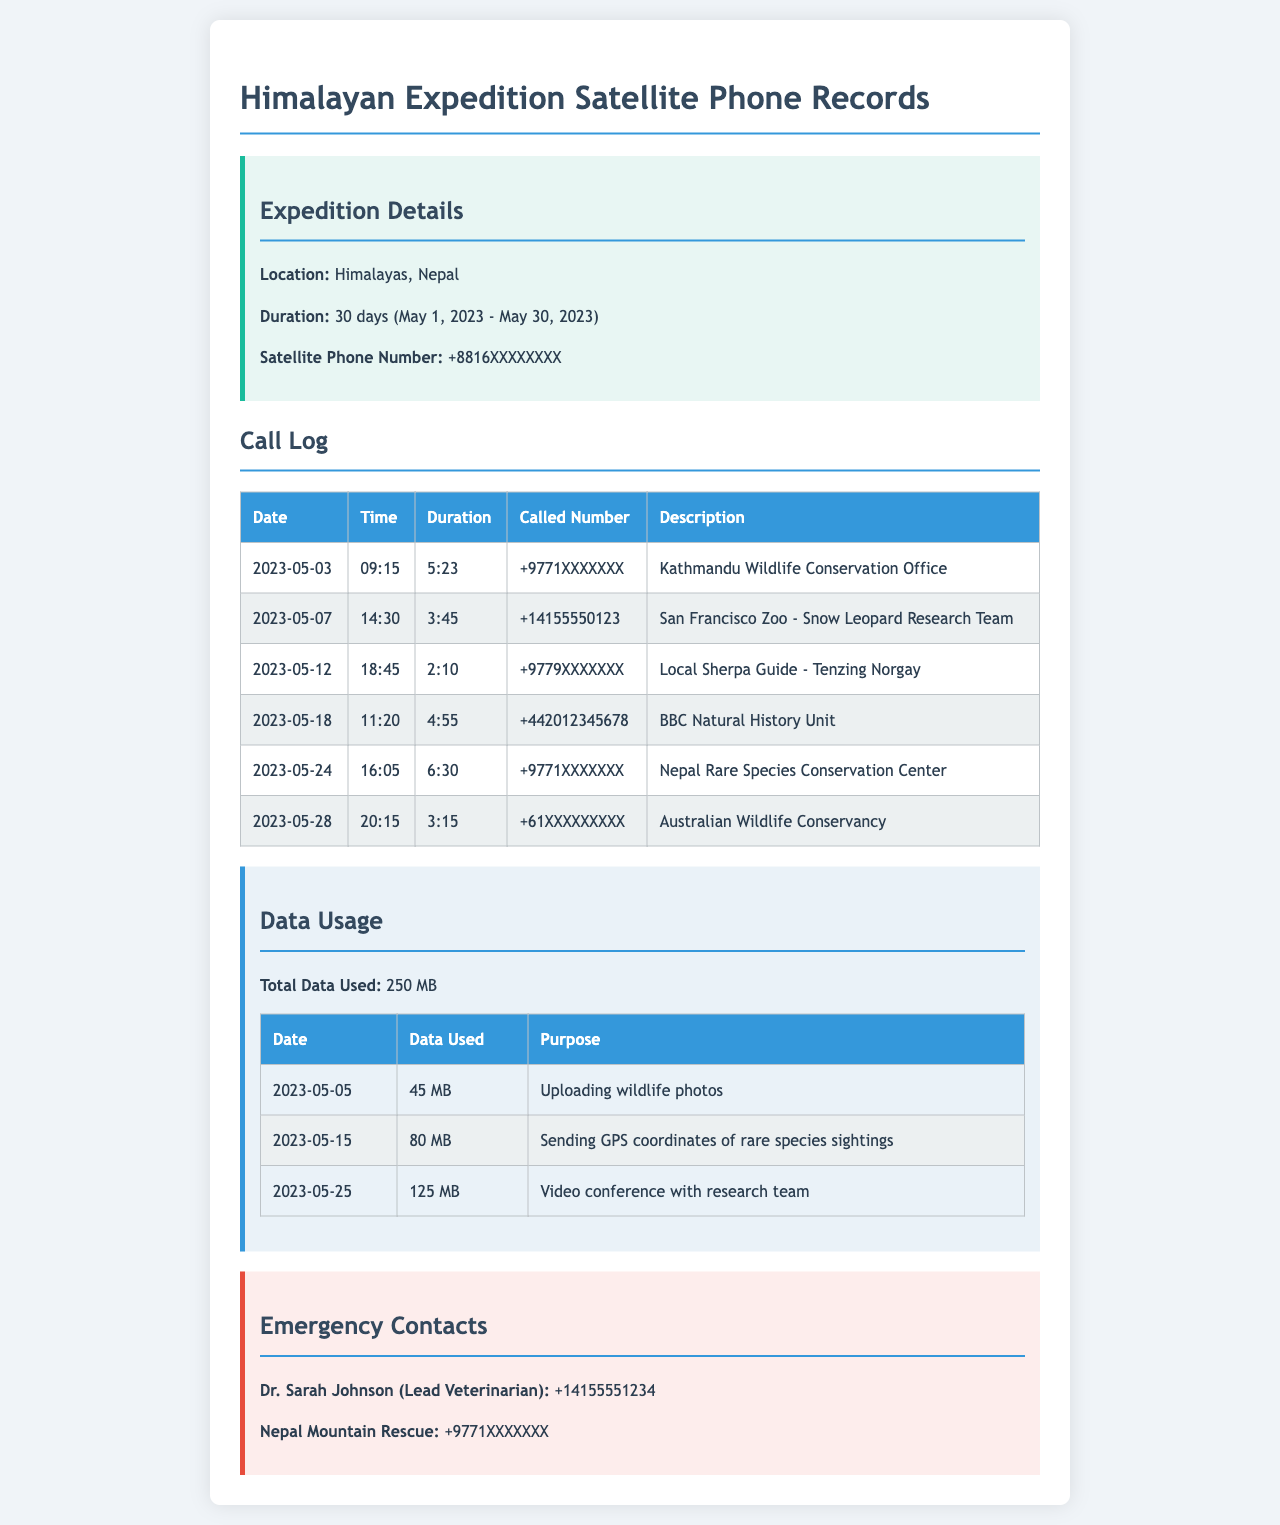what is the satellite phone number? The satellite phone number is a specific detail found in the expedition details section of the document.
Answer: +8816XXXXXXXX what is the total data used? The total data used is indicated clearly in the data usage section.
Answer: 250 MB which organization was contacted on May 7? This is identified in the call log section that lists the dates and corresponding organizations called.
Answer: San Francisco Zoo - Snow Leopard Research Team how long was the call made to the BBC Natural History Unit? The duration of the call to the BBC Natural History Unit is specified in the call log table.
Answer: 4:55 who is the lead veterinarian? The lead veterinarian's name is provided in the emergency contacts section of the document.
Answer: Dr. Sarah Johnson which date had the most data used? By comparing the data usage entries, we can identify the date with the highest data consumption.
Answer: 2023-05-25 how many calls were made to organizations in Nepal? This requires counting the entries in the call log that are affiliated with Nepal.
Answer: 3 what was the purpose of data used on May 15? The purpose of the data used is outlined in the data usage table next to the corresponding date.
Answer: Sending GPS coordinates of rare species sightings what type of document is this? This document contains records related to communication during an expedition, which is typical for maintaining contact in remote areas.
Answer: telephone records 